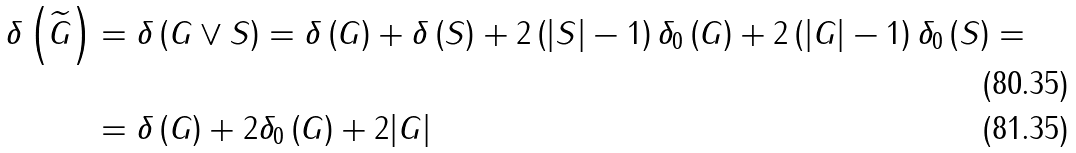Convert formula to latex. <formula><loc_0><loc_0><loc_500><loc_500>\delta \left ( \widetilde { G } \right ) & = \delta \left ( G \lor S \right ) = \delta \left ( G \right ) + \delta \left ( S \right ) + 2 \left ( | S | - 1 \right ) \delta _ { 0 } \left ( G \right ) + 2 \left ( | G | - 1 \right ) \delta _ { 0 } \left ( S \right ) = \\ & = \delta \left ( G \right ) + 2 \delta _ { 0 } \left ( G \right ) + 2 | G |</formula> 